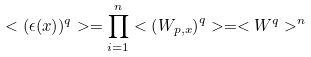Convert formula to latex. <formula><loc_0><loc_0><loc_500><loc_500>< ( \epsilon ( x ) ) ^ { q } > = \prod _ { i = 1 } ^ { n } < \left ( W _ { p , x } \right ) ^ { q } > = < W ^ { q } > ^ { n }</formula> 